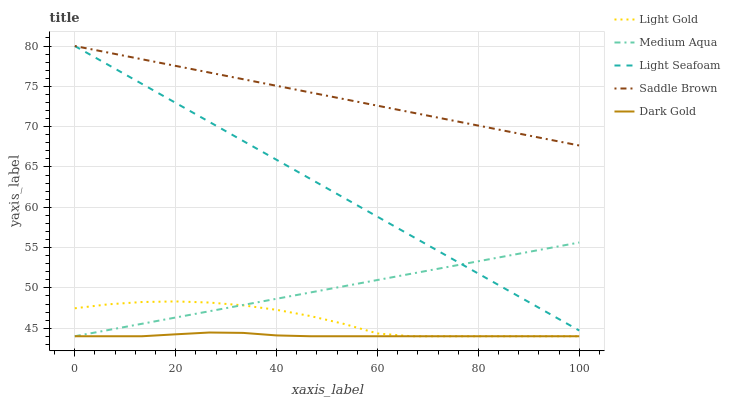Does Light Seafoam have the minimum area under the curve?
Answer yes or no. No. Does Light Seafoam have the maximum area under the curve?
Answer yes or no. No. Is Light Seafoam the smoothest?
Answer yes or no. No. Is Light Seafoam the roughest?
Answer yes or no. No. Does Light Seafoam have the lowest value?
Answer yes or no. No. Does Light Gold have the highest value?
Answer yes or no. No. Is Light Gold less than Saddle Brown?
Answer yes or no. Yes. Is Light Seafoam greater than Dark Gold?
Answer yes or no. Yes. Does Light Gold intersect Saddle Brown?
Answer yes or no. No. 